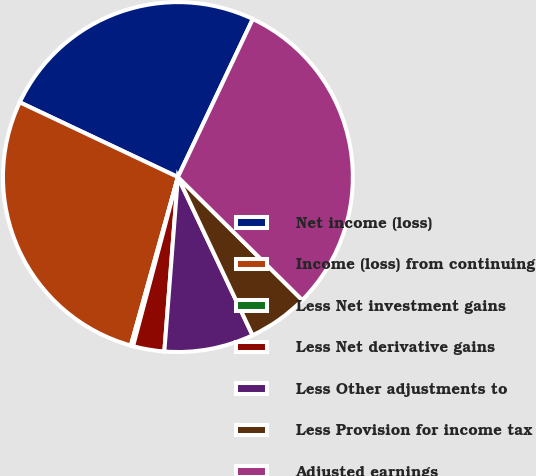Convert chart. <chart><loc_0><loc_0><loc_500><loc_500><pie_chart><fcel>Net income (loss)<fcel>Income (loss) from continuing<fcel>Less Net investment gains<fcel>Less Net derivative gains<fcel>Less Other adjustments to<fcel>Less Provision for income tax<fcel>Adjusted earnings<nl><fcel>25.01%<fcel>27.69%<fcel>0.21%<fcel>2.89%<fcel>8.25%<fcel>5.57%<fcel>30.37%<nl></chart> 